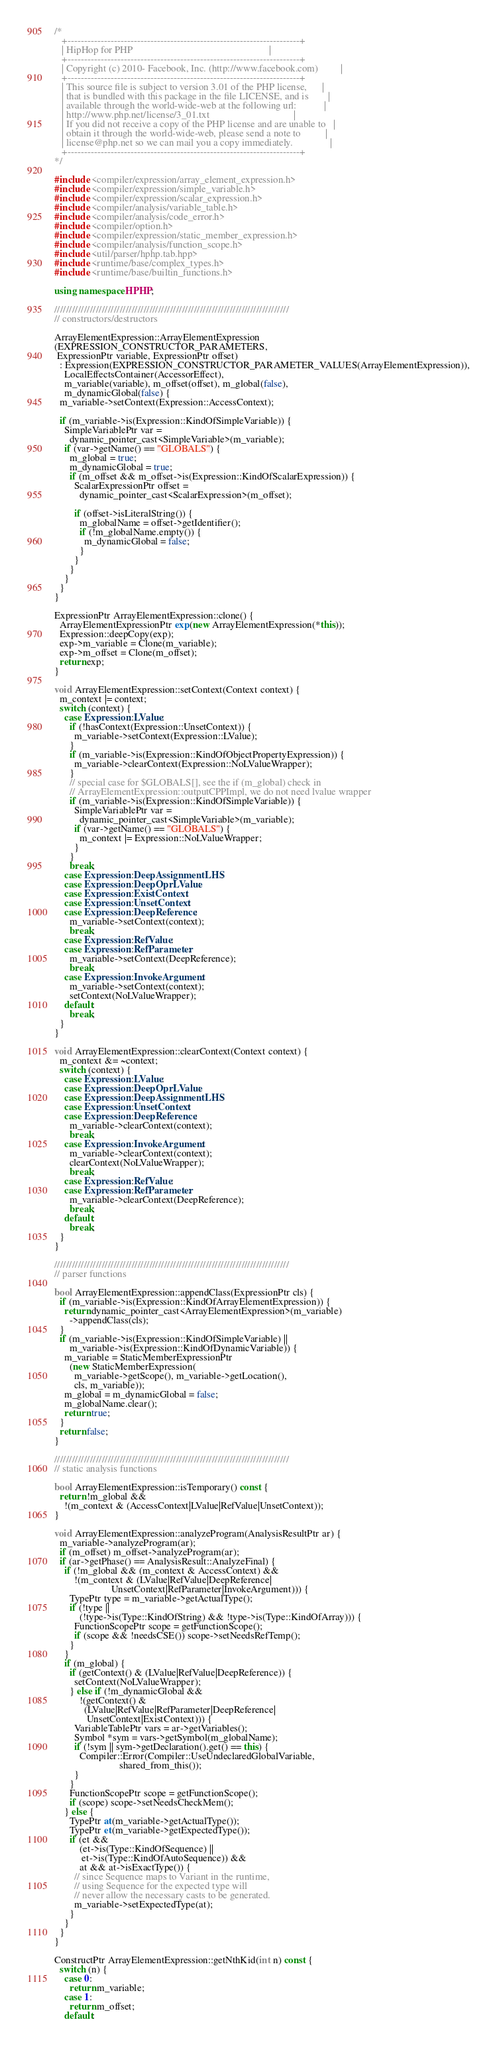<code> <loc_0><loc_0><loc_500><loc_500><_C++_>/*
   +----------------------------------------------------------------------+
   | HipHop for PHP                                                       |
   +----------------------------------------------------------------------+
   | Copyright (c) 2010- Facebook, Inc. (http://www.facebook.com)         |
   +----------------------------------------------------------------------+
   | This source file is subject to version 3.01 of the PHP license,      |
   | that is bundled with this package in the file LICENSE, and is        |
   | available through the world-wide-web at the following url:           |
   | http://www.php.net/license/3_01.txt                                  |
   | If you did not receive a copy of the PHP license and are unable to   |
   | obtain it through the world-wide-web, please send a note to          |
   | license@php.net so we can mail you a copy immediately.               |
   +----------------------------------------------------------------------+
*/

#include <compiler/expression/array_element_expression.h>
#include <compiler/expression/simple_variable.h>
#include <compiler/expression/scalar_expression.h>
#include <compiler/analysis/variable_table.h>
#include <compiler/analysis/code_error.h>
#include <compiler/option.h>
#include <compiler/expression/static_member_expression.h>
#include <compiler/analysis/function_scope.h>
#include <util/parser/hphp.tab.hpp>
#include <runtime/base/complex_types.h>
#include <runtime/base/builtin_functions.h>

using namespace HPHP;

///////////////////////////////////////////////////////////////////////////////
// constructors/destructors

ArrayElementExpression::ArrayElementExpression
(EXPRESSION_CONSTRUCTOR_PARAMETERS,
 ExpressionPtr variable, ExpressionPtr offset)
  : Expression(EXPRESSION_CONSTRUCTOR_PARAMETER_VALUES(ArrayElementExpression)),
    LocalEffectsContainer(AccessorEffect),
    m_variable(variable), m_offset(offset), m_global(false),
    m_dynamicGlobal(false) {
  m_variable->setContext(Expression::AccessContext);

  if (m_variable->is(Expression::KindOfSimpleVariable)) {
    SimpleVariablePtr var =
      dynamic_pointer_cast<SimpleVariable>(m_variable);
    if (var->getName() == "GLOBALS") {
      m_global = true;
      m_dynamicGlobal = true;
      if (m_offset && m_offset->is(Expression::KindOfScalarExpression)) {
        ScalarExpressionPtr offset =
          dynamic_pointer_cast<ScalarExpression>(m_offset);

        if (offset->isLiteralString()) {
          m_globalName = offset->getIdentifier();
          if (!m_globalName.empty()) {
            m_dynamicGlobal = false;
          }
        }
      }
    }
  }
}

ExpressionPtr ArrayElementExpression::clone() {
  ArrayElementExpressionPtr exp(new ArrayElementExpression(*this));
  Expression::deepCopy(exp);
  exp->m_variable = Clone(m_variable);
  exp->m_offset = Clone(m_offset);
  return exp;
}

void ArrayElementExpression::setContext(Context context) {
  m_context |= context;
  switch (context) {
    case Expression::LValue:
      if (!hasContext(Expression::UnsetContext)) {
        m_variable->setContext(Expression::LValue);
      }
      if (m_variable->is(Expression::KindOfObjectPropertyExpression)) {
        m_variable->clearContext(Expression::NoLValueWrapper);
      }
      // special case for $GLOBALS[], see the if (m_global) check in
      // ArrayElementExpression::outputCPPImpl, we do not need lvalue wrapper
      if (m_variable->is(Expression::KindOfSimpleVariable)) {
        SimpleVariablePtr var =
          dynamic_pointer_cast<SimpleVariable>(m_variable);
        if (var->getName() == "GLOBALS") {
          m_context |= Expression::NoLValueWrapper;
        }
      }
      break;
    case Expression::DeepAssignmentLHS:
    case Expression::DeepOprLValue:
    case Expression::ExistContext:
    case Expression::UnsetContext:
    case Expression::DeepReference:
      m_variable->setContext(context);
      break;
    case Expression::RefValue:
    case Expression::RefParameter:
      m_variable->setContext(DeepReference);
      break;
    case Expression::InvokeArgument:
      m_variable->setContext(context);
      setContext(NoLValueWrapper);
    default:
      break;
  }
}

void ArrayElementExpression::clearContext(Context context) {
  m_context &= ~context;
  switch (context) {
    case Expression::LValue:
    case Expression::DeepOprLValue:
    case Expression::DeepAssignmentLHS:
    case Expression::UnsetContext:
    case Expression::DeepReference:
      m_variable->clearContext(context);
      break;
    case Expression::InvokeArgument:
      m_variable->clearContext(context);
      clearContext(NoLValueWrapper);
      break;
    case Expression::RefValue:
    case Expression::RefParameter:
      m_variable->clearContext(DeepReference);
      break;
    default:
      break;
  }
}

///////////////////////////////////////////////////////////////////////////////
// parser functions

bool ArrayElementExpression::appendClass(ExpressionPtr cls) {
  if (m_variable->is(Expression::KindOfArrayElementExpression)) {
    return dynamic_pointer_cast<ArrayElementExpression>(m_variable)
      ->appendClass(cls);
  }
  if (m_variable->is(Expression::KindOfSimpleVariable) ||
      m_variable->is(Expression::KindOfDynamicVariable)) {
    m_variable = StaticMemberExpressionPtr
      (new StaticMemberExpression(
        m_variable->getScope(), m_variable->getLocation(),
        cls, m_variable));
    m_global = m_dynamicGlobal = false;
    m_globalName.clear();
    return true;
  }
  return false;
}

///////////////////////////////////////////////////////////////////////////////
// static analysis functions

bool ArrayElementExpression::isTemporary() const {
  return !m_global &&
    !(m_context & (AccessContext|LValue|RefValue|UnsetContext));
}

void ArrayElementExpression::analyzeProgram(AnalysisResultPtr ar) {
  m_variable->analyzeProgram(ar);
  if (m_offset) m_offset->analyzeProgram(ar);
  if (ar->getPhase() == AnalysisResult::AnalyzeFinal) {
    if (!m_global && (m_context & AccessContext) &&
        !(m_context & (LValue|RefValue|DeepReference|
                       UnsetContext|RefParameter|InvokeArgument))) {
      TypePtr type = m_variable->getActualType();
      if (!type ||
          (!type->is(Type::KindOfString) && !type->is(Type::KindOfArray))) {
        FunctionScopePtr scope = getFunctionScope();
        if (scope && !needsCSE()) scope->setNeedsRefTemp();
      }
    }
    if (m_global) {
      if (getContext() & (LValue|RefValue|DeepReference)) {
        setContext(NoLValueWrapper);
      } else if (!m_dynamicGlobal &&
          !(getContext() &
            (LValue|RefValue|RefParameter|DeepReference|
             UnsetContext|ExistContext))) {
        VariableTablePtr vars = ar->getVariables();
        Symbol *sym = vars->getSymbol(m_globalName);
        if (!sym || sym->getDeclaration().get() == this) {
          Compiler::Error(Compiler::UseUndeclaredGlobalVariable,
                          shared_from_this());
        }
      }
      FunctionScopePtr scope = getFunctionScope();
      if (scope) scope->setNeedsCheckMem();
    } else {
      TypePtr at(m_variable->getActualType());
      TypePtr et(m_variable->getExpectedType());
      if (et &&
          (et->is(Type::KindOfSequence) ||
           et->is(Type::KindOfAutoSequence)) &&
          at && at->isExactType()) {
        // since Sequence maps to Variant in the runtime,
        // using Sequence for the expected type will
        // never allow the necessary casts to be generated.
        m_variable->setExpectedType(at);
      }
    }
  }
}

ConstructPtr ArrayElementExpression::getNthKid(int n) const {
  switch (n) {
    case 0:
      return m_variable;
    case 1:
      return m_offset;
    default:</code> 